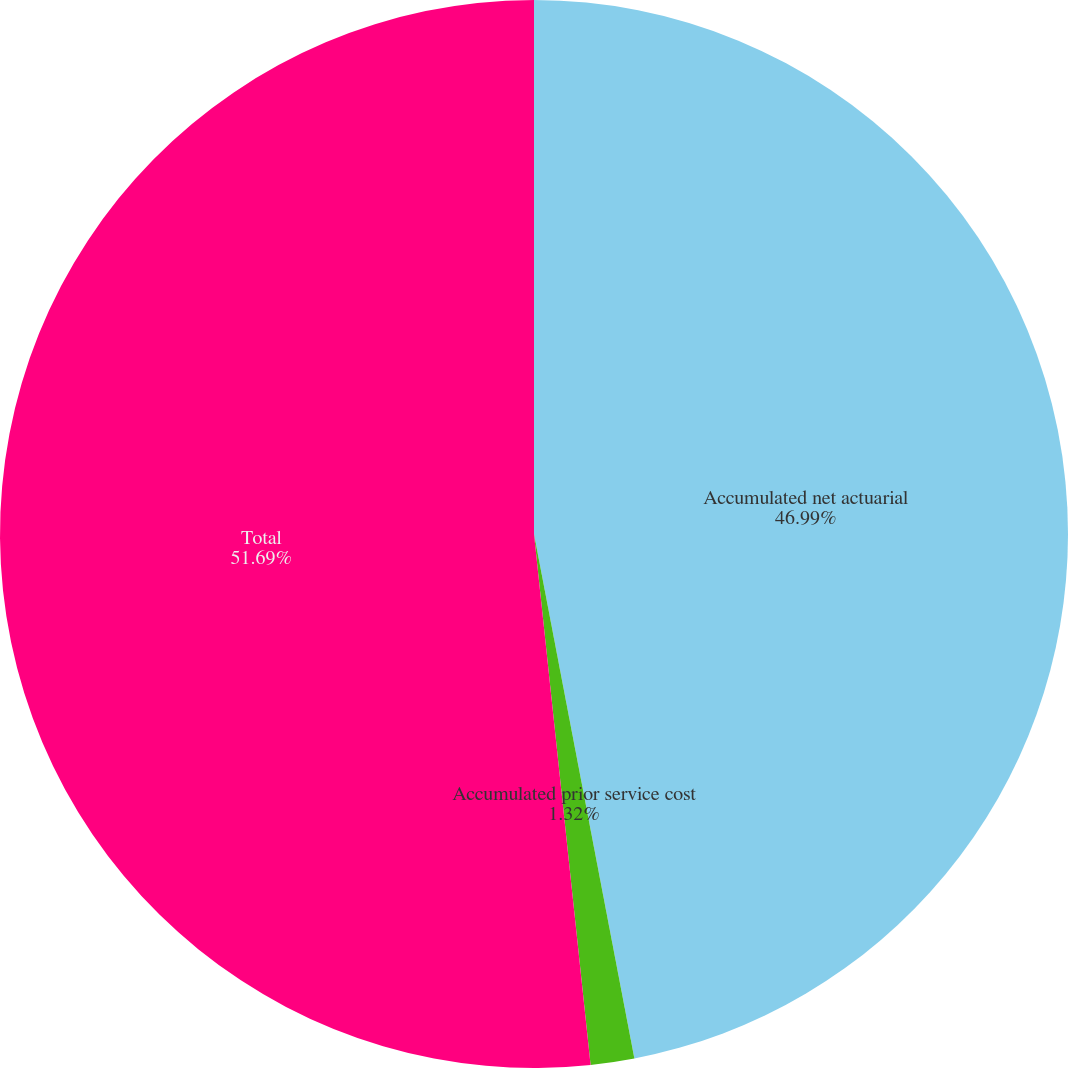Convert chart. <chart><loc_0><loc_0><loc_500><loc_500><pie_chart><fcel>Accumulated net actuarial<fcel>Accumulated prior service cost<fcel>Total<nl><fcel>46.99%<fcel>1.32%<fcel>51.69%<nl></chart> 